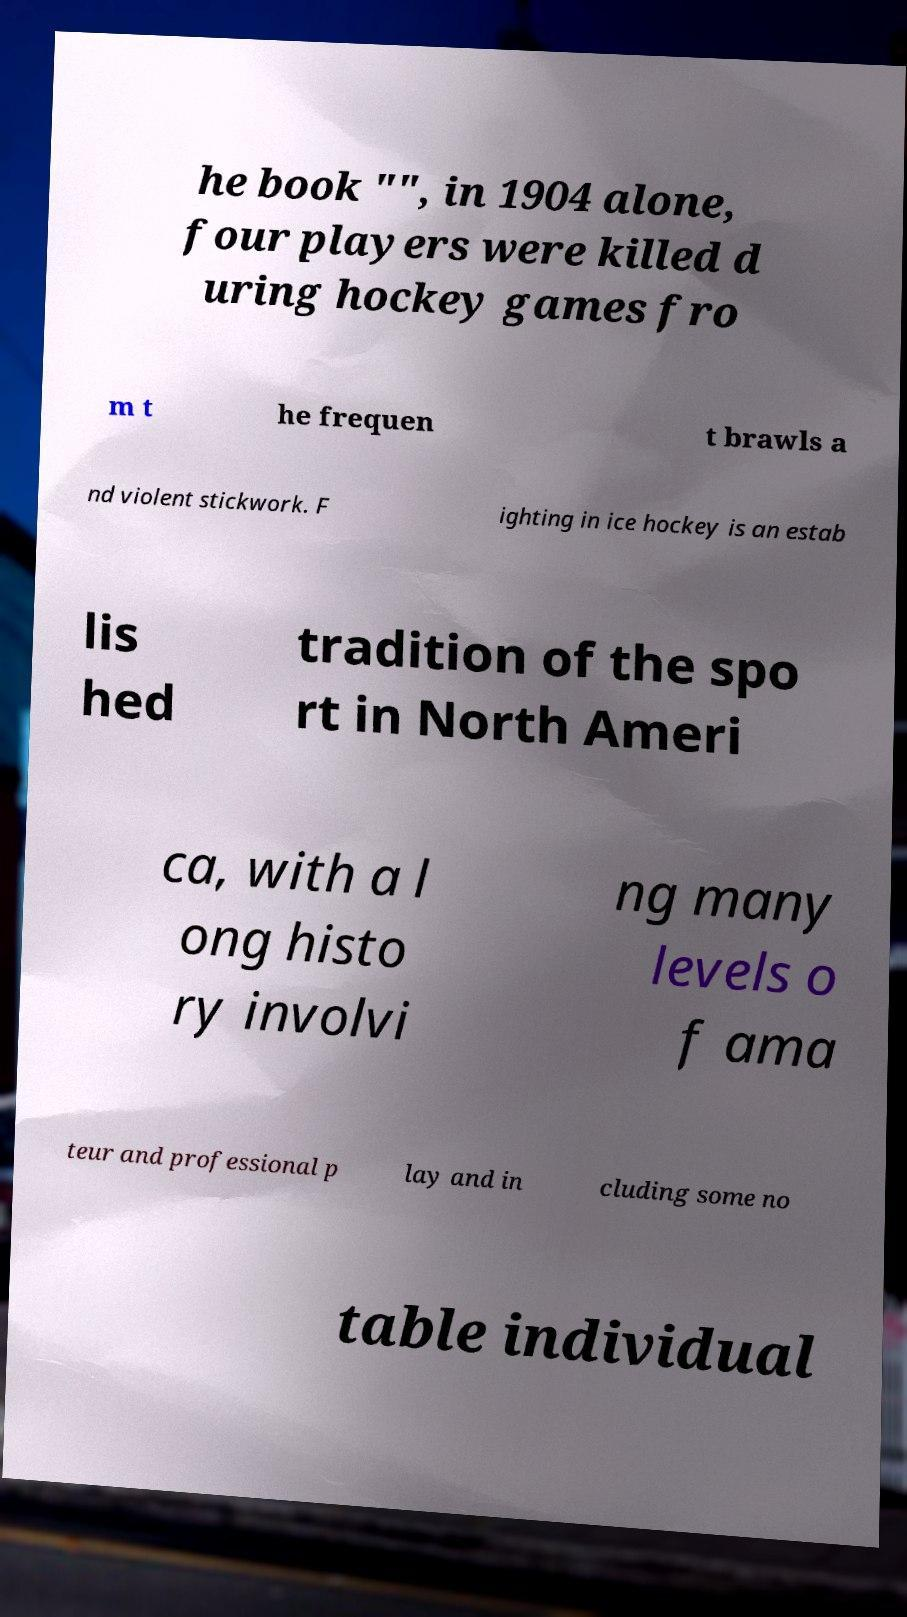Could you extract and type out the text from this image? he book "", in 1904 alone, four players were killed d uring hockey games fro m t he frequen t brawls a nd violent stickwork. F ighting in ice hockey is an estab lis hed tradition of the spo rt in North Ameri ca, with a l ong histo ry involvi ng many levels o f ama teur and professional p lay and in cluding some no table individual 